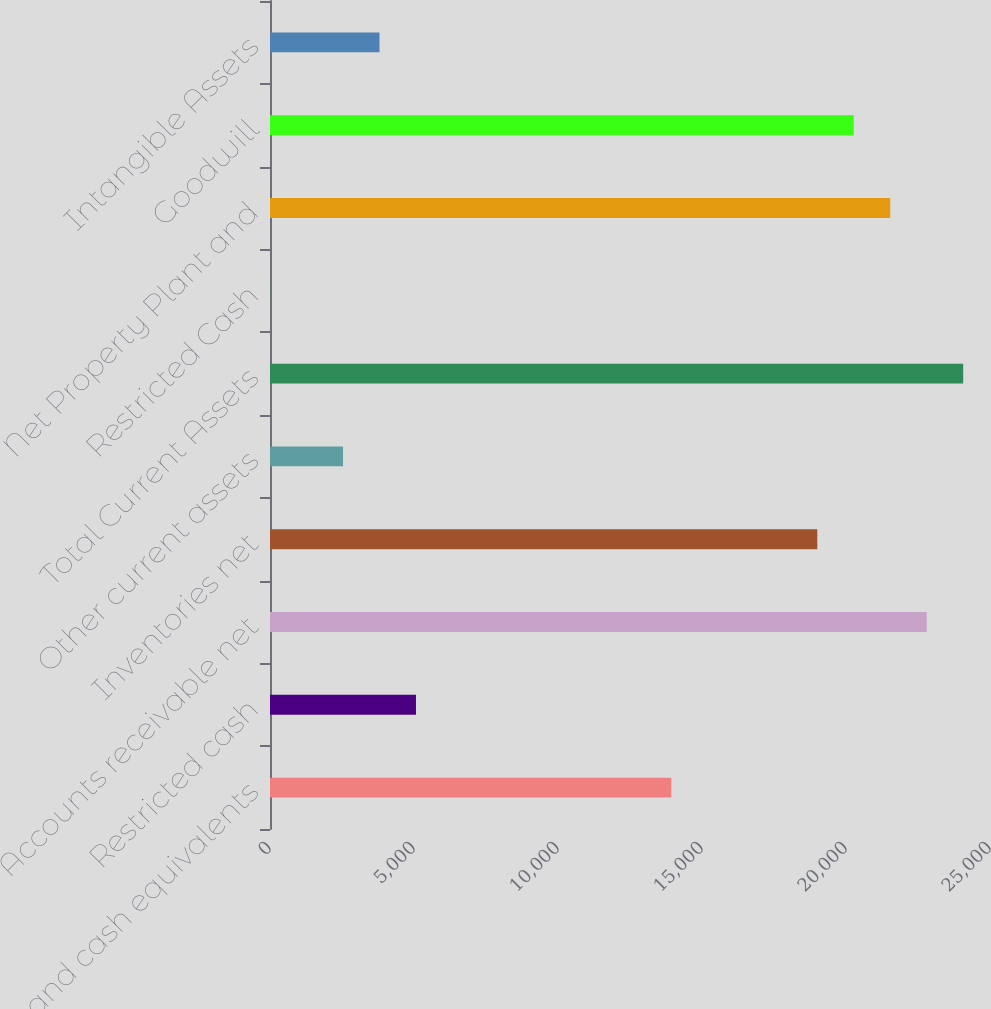Convert chart. <chart><loc_0><loc_0><loc_500><loc_500><bar_chart><fcel>Cash and cash equivalents<fcel>Restricted cash<fcel>Accounts receivable net<fcel>Inventories net<fcel>Other current assets<fcel>Total Current Assets<fcel>Restricted Cash<fcel>Net Property Plant and<fcel>Goodwill<fcel>Intangible Assets<nl><fcel>13935.7<fcel>5068.7<fcel>22802.8<fcel>19002.6<fcel>2535.26<fcel>24069.5<fcel>1.82<fcel>21536.1<fcel>20269.3<fcel>3801.98<nl></chart> 